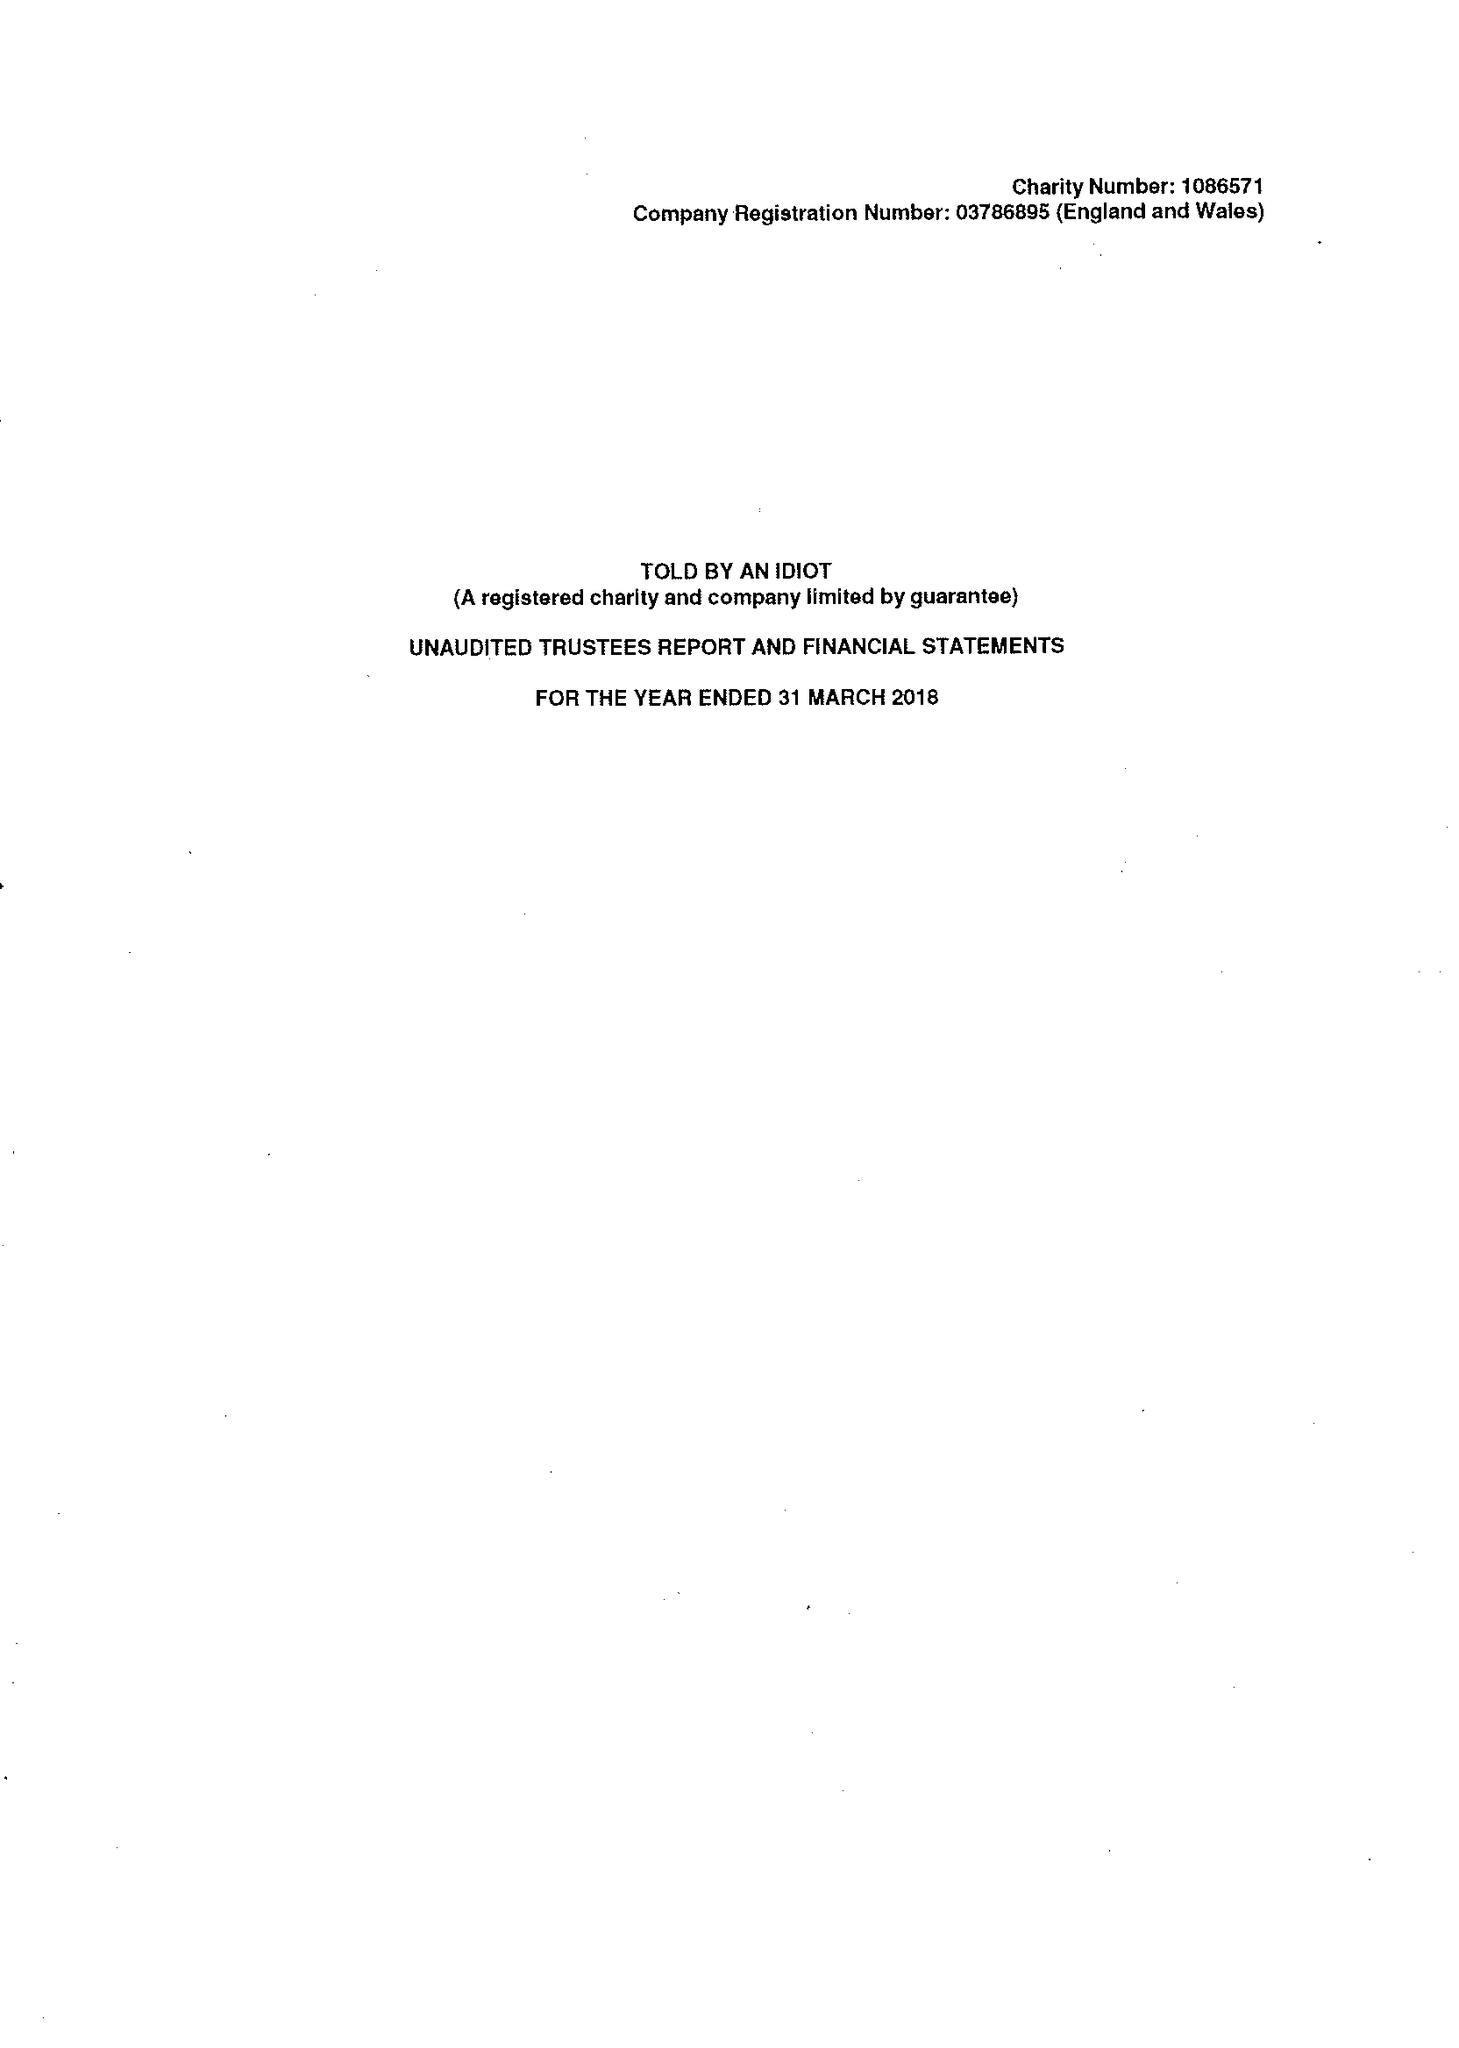What is the value for the address__post_town?
Answer the question using a single word or phrase. LONDON 